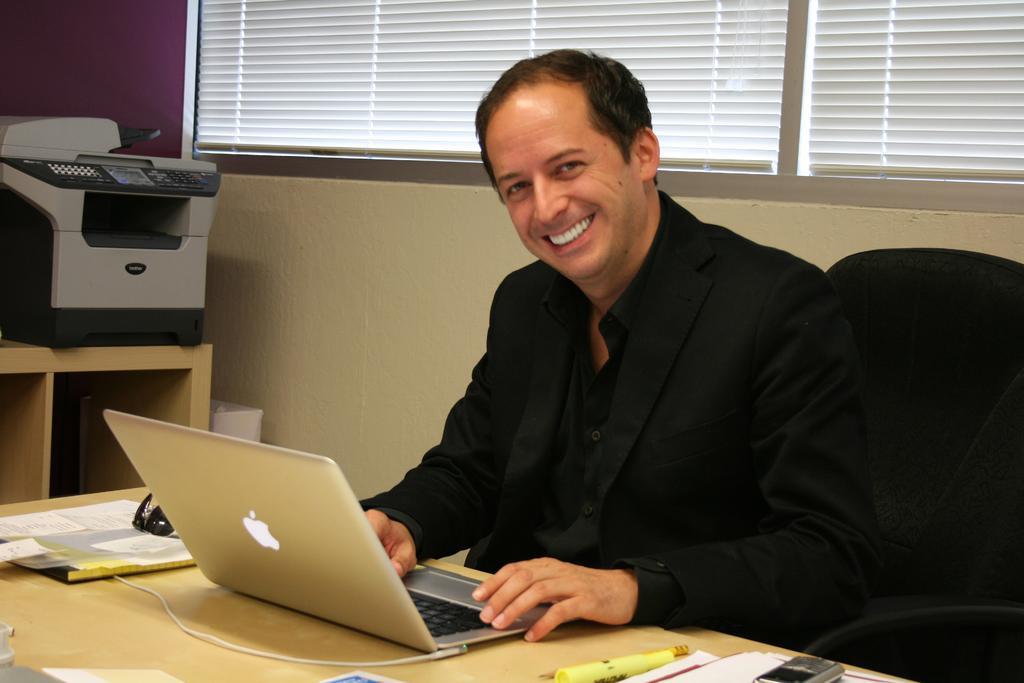Could you give a brief overview of what you see in this image? In this image I can see a man is sitting on a chair. I can also see a smile on his face and he is wearing a blazer. On this table I can see few papers and a laptop. In the background I can see a printer machine. 